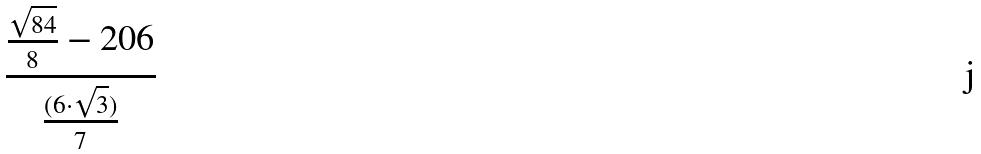Convert formula to latex. <formula><loc_0><loc_0><loc_500><loc_500>\frac { \frac { \sqrt { 8 4 } } { 8 } - 2 0 6 } { \frac { ( 6 \cdot \sqrt { 3 } ) } { 7 } }</formula> 